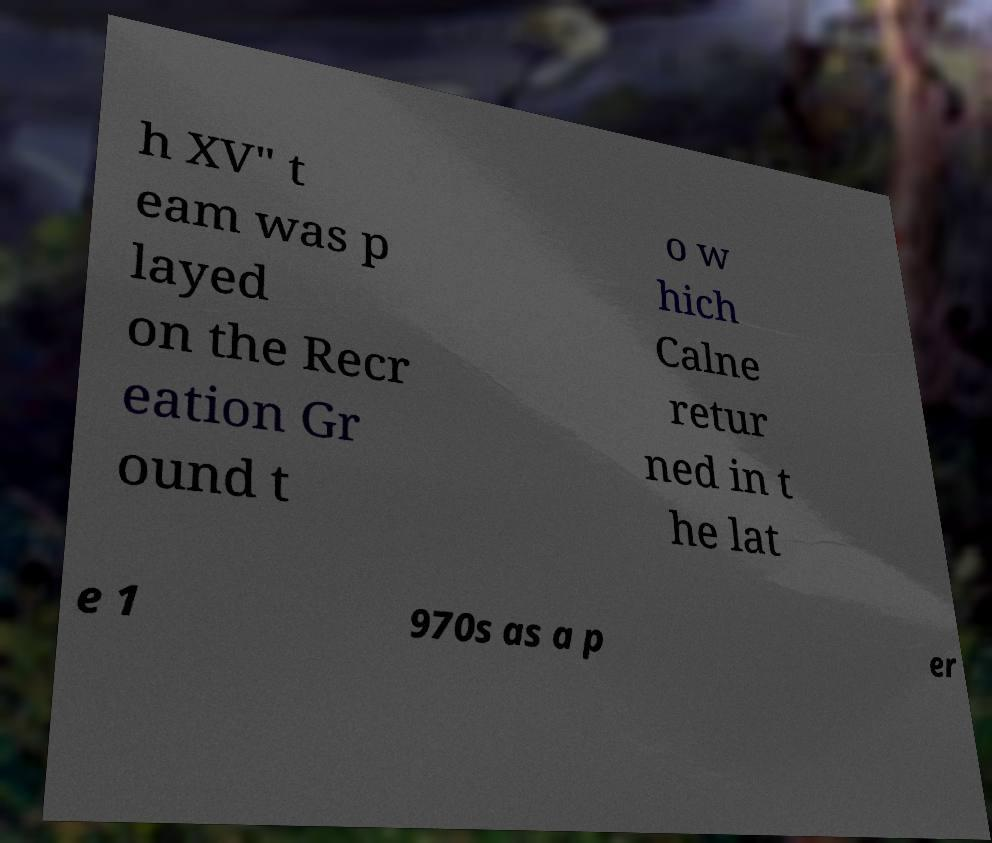I need the written content from this picture converted into text. Can you do that? h XV" t eam was p layed on the Recr eation Gr ound t o w hich Calne retur ned in t he lat e 1 970s as a p er 